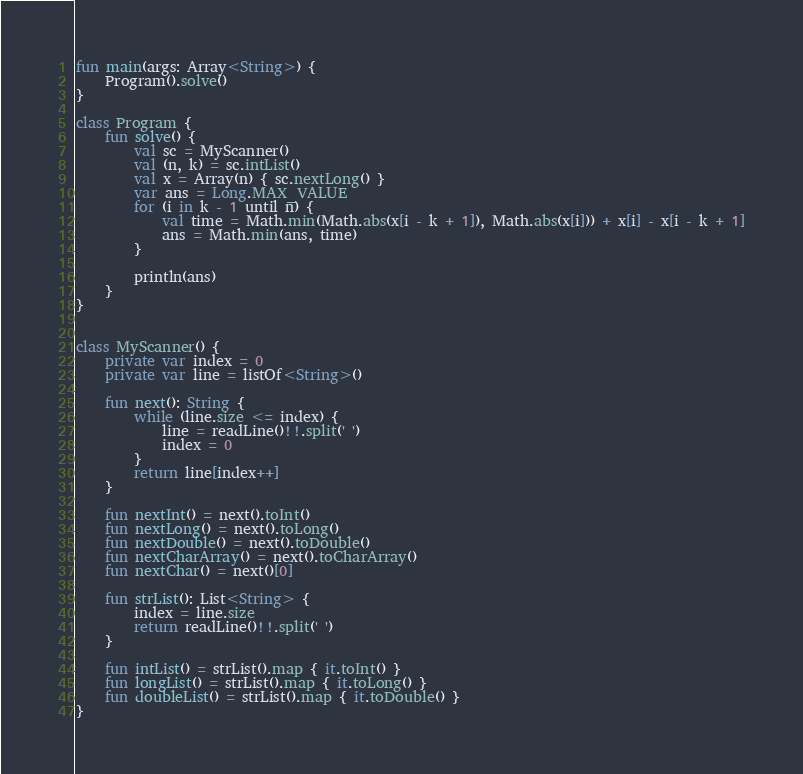<code> <loc_0><loc_0><loc_500><loc_500><_Kotlin_>fun main(args: Array<String>) {
    Program().solve()
}

class Program {
    fun solve() {
        val sc = MyScanner()
        val (n, k) = sc.intList()
        val x = Array(n) { sc.nextLong() }
        var ans = Long.MAX_VALUE
        for (i in k - 1 until n) {
            val time = Math.min(Math.abs(x[i - k + 1]), Math.abs(x[i])) + x[i] - x[i - k + 1]
            ans = Math.min(ans, time)
        }

        println(ans)
    }
}


class MyScanner() {
    private var index = 0
    private var line = listOf<String>()

    fun next(): String {
        while (line.size <= index) {
            line = readLine()!!.split(' ')
            index = 0
        }
        return line[index++]
    }

    fun nextInt() = next().toInt()
    fun nextLong() = next().toLong()
    fun nextDouble() = next().toDouble()
    fun nextCharArray() = next().toCharArray()
    fun nextChar() = next()[0]

    fun strList(): List<String> {
        index = line.size
        return readLine()!!.split(' ')
    }

    fun intList() = strList().map { it.toInt() }
    fun longList() = strList().map { it.toLong() }
    fun doubleList() = strList().map { it.toDouble() }
}</code> 